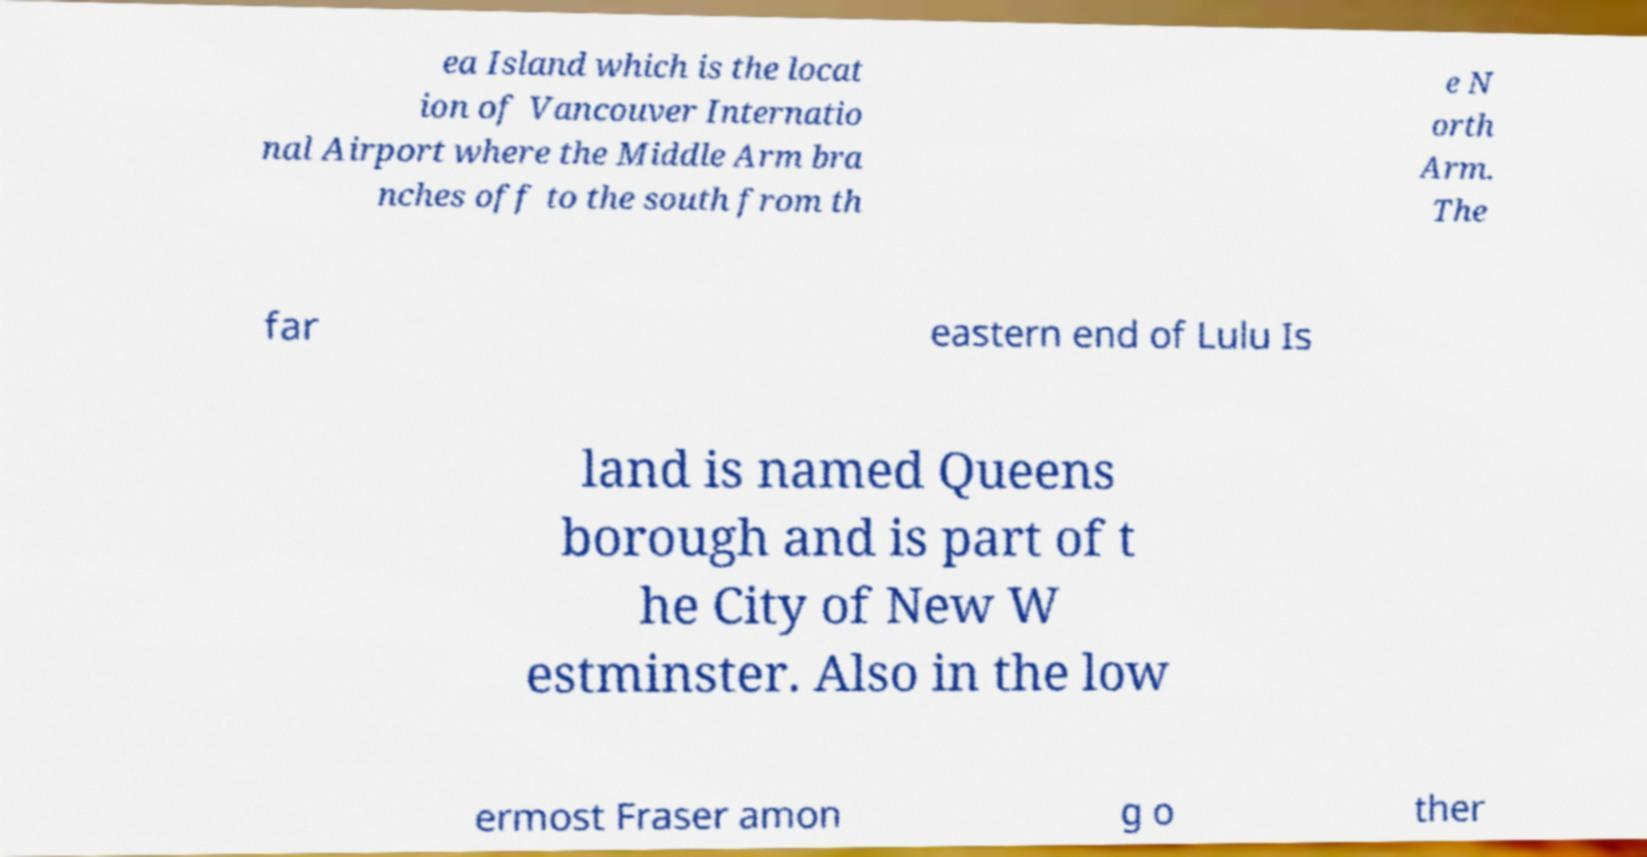There's text embedded in this image that I need extracted. Can you transcribe it verbatim? ea Island which is the locat ion of Vancouver Internatio nal Airport where the Middle Arm bra nches off to the south from th e N orth Arm. The far eastern end of Lulu Is land is named Queens borough and is part of t he City of New W estminster. Also in the low ermost Fraser amon g o ther 